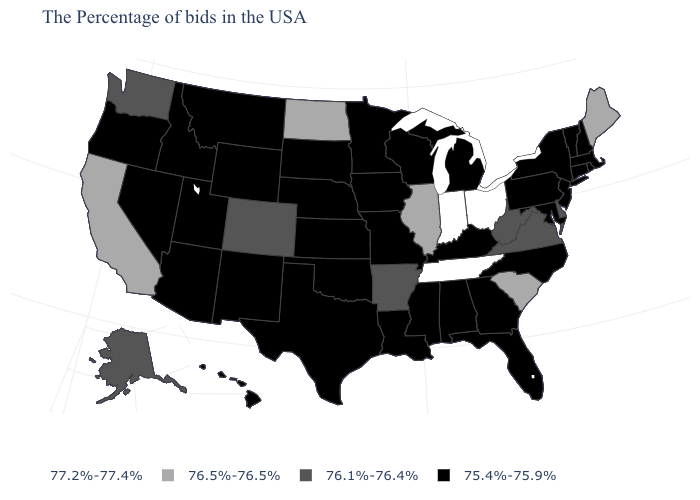What is the value of Washington?
Give a very brief answer. 76.1%-76.4%. How many symbols are there in the legend?
Concise answer only. 4. Name the states that have a value in the range 75.4%-75.9%?
Quick response, please. Massachusetts, Rhode Island, New Hampshire, Vermont, Connecticut, New York, New Jersey, Maryland, Pennsylvania, North Carolina, Florida, Georgia, Michigan, Kentucky, Alabama, Wisconsin, Mississippi, Louisiana, Missouri, Minnesota, Iowa, Kansas, Nebraska, Oklahoma, Texas, South Dakota, Wyoming, New Mexico, Utah, Montana, Arizona, Idaho, Nevada, Oregon, Hawaii. What is the value of Hawaii?
Write a very short answer. 75.4%-75.9%. Is the legend a continuous bar?
Write a very short answer. No. How many symbols are there in the legend?
Answer briefly. 4. Name the states that have a value in the range 76.1%-76.4%?
Give a very brief answer. Delaware, Virginia, West Virginia, Arkansas, Colorado, Washington, Alaska. Does Wisconsin have the highest value in the MidWest?
Quick response, please. No. Name the states that have a value in the range 76.1%-76.4%?
Write a very short answer. Delaware, Virginia, West Virginia, Arkansas, Colorado, Washington, Alaska. Among the states that border Alabama , does Florida have the lowest value?
Short answer required. Yes. What is the value of Kansas?
Short answer required. 75.4%-75.9%. Does the first symbol in the legend represent the smallest category?
Answer briefly. No. What is the highest value in the USA?
Be succinct. 77.2%-77.4%. Name the states that have a value in the range 77.2%-77.4%?
Give a very brief answer. Ohio, Indiana, Tennessee. Does Maine have the lowest value in the Northeast?
Quick response, please. No. 